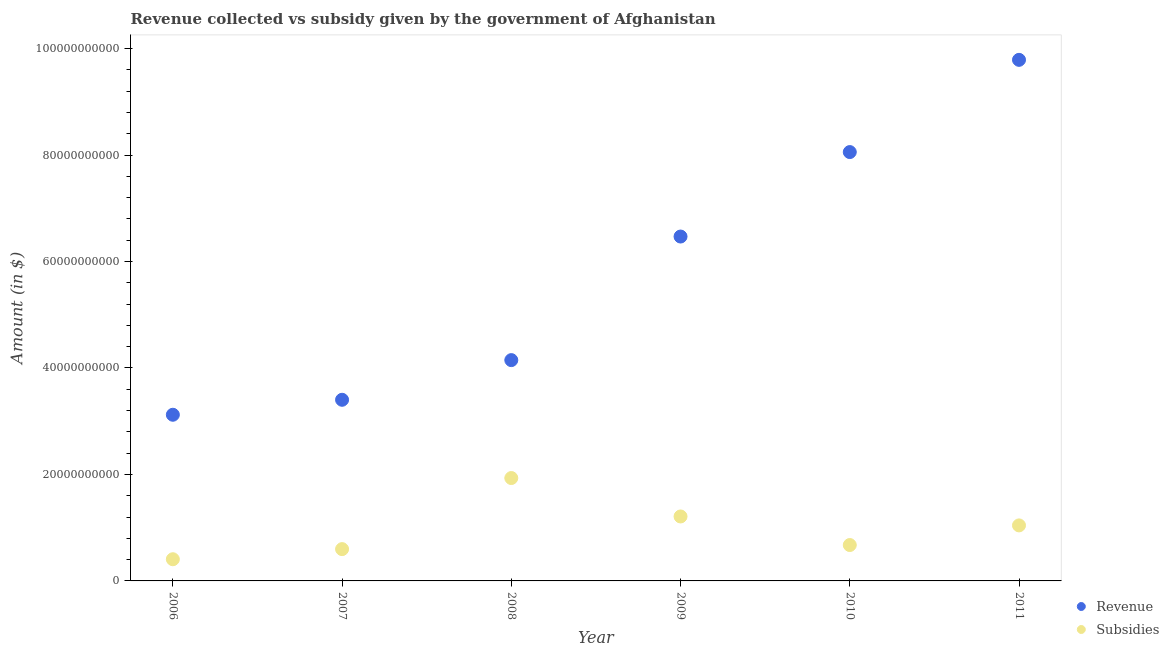What is the amount of revenue collected in 2007?
Provide a short and direct response. 3.40e+1. Across all years, what is the maximum amount of revenue collected?
Offer a terse response. 9.79e+1. Across all years, what is the minimum amount of subsidies given?
Keep it short and to the point. 4.07e+09. In which year was the amount of revenue collected maximum?
Provide a succinct answer. 2011. What is the total amount of revenue collected in the graph?
Provide a succinct answer. 3.50e+11. What is the difference between the amount of subsidies given in 2009 and that in 2010?
Offer a terse response. 5.37e+09. What is the difference between the amount of revenue collected in 2010 and the amount of subsidies given in 2006?
Keep it short and to the point. 7.65e+1. What is the average amount of revenue collected per year?
Offer a terse response. 5.83e+1. In the year 2008, what is the difference between the amount of subsidies given and amount of revenue collected?
Provide a succinct answer. -2.22e+1. What is the ratio of the amount of subsidies given in 2006 to that in 2011?
Your answer should be very brief. 0.39. What is the difference between the highest and the second highest amount of revenue collected?
Provide a short and direct response. 1.73e+1. What is the difference between the highest and the lowest amount of revenue collected?
Your answer should be compact. 6.67e+1. Is the sum of the amount of revenue collected in 2007 and 2010 greater than the maximum amount of subsidies given across all years?
Keep it short and to the point. Yes. Is the amount of revenue collected strictly less than the amount of subsidies given over the years?
Make the answer very short. No. What is the difference between two consecutive major ticks on the Y-axis?
Give a very brief answer. 2.00e+1. Are the values on the major ticks of Y-axis written in scientific E-notation?
Your answer should be compact. No. Does the graph contain any zero values?
Keep it short and to the point. No. How are the legend labels stacked?
Keep it short and to the point. Vertical. What is the title of the graph?
Ensure brevity in your answer.  Revenue collected vs subsidy given by the government of Afghanistan. Does "constant 2005 US$" appear as one of the legend labels in the graph?
Offer a very short reply. No. What is the label or title of the Y-axis?
Make the answer very short. Amount (in $). What is the Amount (in $) of Revenue in 2006?
Your response must be concise. 3.12e+1. What is the Amount (in $) of Subsidies in 2006?
Provide a short and direct response. 4.07e+09. What is the Amount (in $) in Revenue in 2007?
Give a very brief answer. 3.40e+1. What is the Amount (in $) of Subsidies in 2007?
Provide a short and direct response. 5.97e+09. What is the Amount (in $) of Revenue in 2008?
Provide a succinct answer. 4.15e+1. What is the Amount (in $) in Subsidies in 2008?
Give a very brief answer. 1.93e+1. What is the Amount (in $) in Revenue in 2009?
Provide a succinct answer. 6.47e+1. What is the Amount (in $) in Subsidies in 2009?
Offer a very short reply. 1.21e+1. What is the Amount (in $) in Revenue in 2010?
Your answer should be very brief. 8.06e+1. What is the Amount (in $) of Subsidies in 2010?
Make the answer very short. 6.74e+09. What is the Amount (in $) in Revenue in 2011?
Offer a terse response. 9.79e+1. What is the Amount (in $) in Subsidies in 2011?
Your answer should be compact. 1.04e+1. Across all years, what is the maximum Amount (in $) of Revenue?
Keep it short and to the point. 9.79e+1. Across all years, what is the maximum Amount (in $) of Subsidies?
Keep it short and to the point. 1.93e+1. Across all years, what is the minimum Amount (in $) in Revenue?
Your response must be concise. 3.12e+1. Across all years, what is the minimum Amount (in $) of Subsidies?
Ensure brevity in your answer.  4.07e+09. What is the total Amount (in $) in Revenue in the graph?
Ensure brevity in your answer.  3.50e+11. What is the total Amount (in $) in Subsidies in the graph?
Your answer should be very brief. 5.86e+1. What is the difference between the Amount (in $) of Revenue in 2006 and that in 2007?
Provide a short and direct response. -2.81e+09. What is the difference between the Amount (in $) in Subsidies in 2006 and that in 2007?
Keep it short and to the point. -1.90e+09. What is the difference between the Amount (in $) in Revenue in 2006 and that in 2008?
Your response must be concise. -1.03e+1. What is the difference between the Amount (in $) in Subsidies in 2006 and that in 2008?
Offer a terse response. -1.53e+1. What is the difference between the Amount (in $) in Revenue in 2006 and that in 2009?
Ensure brevity in your answer.  -3.35e+1. What is the difference between the Amount (in $) in Subsidies in 2006 and that in 2009?
Provide a short and direct response. -8.03e+09. What is the difference between the Amount (in $) in Revenue in 2006 and that in 2010?
Make the answer very short. -4.93e+1. What is the difference between the Amount (in $) of Subsidies in 2006 and that in 2010?
Provide a succinct answer. -2.67e+09. What is the difference between the Amount (in $) in Revenue in 2006 and that in 2011?
Your answer should be very brief. -6.67e+1. What is the difference between the Amount (in $) in Subsidies in 2006 and that in 2011?
Offer a terse response. -6.36e+09. What is the difference between the Amount (in $) of Revenue in 2007 and that in 2008?
Provide a short and direct response. -7.45e+09. What is the difference between the Amount (in $) in Subsidies in 2007 and that in 2008?
Provide a short and direct response. -1.34e+1. What is the difference between the Amount (in $) in Revenue in 2007 and that in 2009?
Offer a terse response. -3.07e+1. What is the difference between the Amount (in $) of Subsidies in 2007 and that in 2009?
Your response must be concise. -6.13e+09. What is the difference between the Amount (in $) in Revenue in 2007 and that in 2010?
Your answer should be very brief. -4.65e+1. What is the difference between the Amount (in $) in Subsidies in 2007 and that in 2010?
Make the answer very short. -7.68e+08. What is the difference between the Amount (in $) in Revenue in 2007 and that in 2011?
Provide a short and direct response. -6.39e+1. What is the difference between the Amount (in $) in Subsidies in 2007 and that in 2011?
Provide a short and direct response. -4.46e+09. What is the difference between the Amount (in $) of Revenue in 2008 and that in 2009?
Your response must be concise. -2.32e+1. What is the difference between the Amount (in $) in Subsidies in 2008 and that in 2009?
Offer a very short reply. 7.22e+09. What is the difference between the Amount (in $) of Revenue in 2008 and that in 2010?
Keep it short and to the point. -3.91e+1. What is the difference between the Amount (in $) of Subsidies in 2008 and that in 2010?
Provide a short and direct response. 1.26e+1. What is the difference between the Amount (in $) of Revenue in 2008 and that in 2011?
Give a very brief answer. -5.64e+1. What is the difference between the Amount (in $) of Subsidies in 2008 and that in 2011?
Keep it short and to the point. 8.90e+09. What is the difference between the Amount (in $) in Revenue in 2009 and that in 2010?
Make the answer very short. -1.59e+1. What is the difference between the Amount (in $) of Subsidies in 2009 and that in 2010?
Make the answer very short. 5.37e+09. What is the difference between the Amount (in $) in Revenue in 2009 and that in 2011?
Keep it short and to the point. -3.32e+1. What is the difference between the Amount (in $) in Subsidies in 2009 and that in 2011?
Provide a succinct answer. 1.68e+09. What is the difference between the Amount (in $) of Revenue in 2010 and that in 2011?
Your response must be concise. -1.73e+1. What is the difference between the Amount (in $) of Subsidies in 2010 and that in 2011?
Your response must be concise. -3.69e+09. What is the difference between the Amount (in $) in Revenue in 2006 and the Amount (in $) in Subsidies in 2007?
Give a very brief answer. 2.52e+1. What is the difference between the Amount (in $) in Revenue in 2006 and the Amount (in $) in Subsidies in 2008?
Keep it short and to the point. 1.19e+1. What is the difference between the Amount (in $) in Revenue in 2006 and the Amount (in $) in Subsidies in 2009?
Keep it short and to the point. 1.91e+1. What is the difference between the Amount (in $) in Revenue in 2006 and the Amount (in $) in Subsidies in 2010?
Ensure brevity in your answer.  2.45e+1. What is the difference between the Amount (in $) in Revenue in 2006 and the Amount (in $) in Subsidies in 2011?
Give a very brief answer. 2.08e+1. What is the difference between the Amount (in $) of Revenue in 2007 and the Amount (in $) of Subsidies in 2008?
Your answer should be very brief. 1.47e+1. What is the difference between the Amount (in $) in Revenue in 2007 and the Amount (in $) in Subsidies in 2009?
Keep it short and to the point. 2.19e+1. What is the difference between the Amount (in $) of Revenue in 2007 and the Amount (in $) of Subsidies in 2010?
Offer a very short reply. 2.73e+1. What is the difference between the Amount (in $) in Revenue in 2007 and the Amount (in $) in Subsidies in 2011?
Your response must be concise. 2.36e+1. What is the difference between the Amount (in $) of Revenue in 2008 and the Amount (in $) of Subsidies in 2009?
Your response must be concise. 2.94e+1. What is the difference between the Amount (in $) in Revenue in 2008 and the Amount (in $) in Subsidies in 2010?
Give a very brief answer. 3.47e+1. What is the difference between the Amount (in $) of Revenue in 2008 and the Amount (in $) of Subsidies in 2011?
Provide a succinct answer. 3.10e+1. What is the difference between the Amount (in $) of Revenue in 2009 and the Amount (in $) of Subsidies in 2010?
Offer a very short reply. 5.79e+1. What is the difference between the Amount (in $) of Revenue in 2009 and the Amount (in $) of Subsidies in 2011?
Ensure brevity in your answer.  5.43e+1. What is the difference between the Amount (in $) in Revenue in 2010 and the Amount (in $) in Subsidies in 2011?
Your answer should be very brief. 7.01e+1. What is the average Amount (in $) of Revenue per year?
Give a very brief answer. 5.83e+1. What is the average Amount (in $) in Subsidies per year?
Your answer should be very brief. 9.77e+09. In the year 2006, what is the difference between the Amount (in $) of Revenue and Amount (in $) of Subsidies?
Provide a short and direct response. 2.71e+1. In the year 2007, what is the difference between the Amount (in $) in Revenue and Amount (in $) in Subsidies?
Keep it short and to the point. 2.81e+1. In the year 2008, what is the difference between the Amount (in $) of Revenue and Amount (in $) of Subsidies?
Ensure brevity in your answer.  2.22e+1. In the year 2009, what is the difference between the Amount (in $) of Revenue and Amount (in $) of Subsidies?
Your answer should be very brief. 5.26e+1. In the year 2010, what is the difference between the Amount (in $) in Revenue and Amount (in $) in Subsidies?
Offer a terse response. 7.38e+1. In the year 2011, what is the difference between the Amount (in $) of Revenue and Amount (in $) of Subsidies?
Provide a succinct answer. 8.74e+1. What is the ratio of the Amount (in $) in Revenue in 2006 to that in 2007?
Keep it short and to the point. 0.92. What is the ratio of the Amount (in $) of Subsidies in 2006 to that in 2007?
Give a very brief answer. 0.68. What is the ratio of the Amount (in $) of Revenue in 2006 to that in 2008?
Give a very brief answer. 0.75. What is the ratio of the Amount (in $) of Subsidies in 2006 to that in 2008?
Give a very brief answer. 0.21. What is the ratio of the Amount (in $) of Revenue in 2006 to that in 2009?
Offer a very short reply. 0.48. What is the ratio of the Amount (in $) of Subsidies in 2006 to that in 2009?
Offer a terse response. 0.34. What is the ratio of the Amount (in $) in Revenue in 2006 to that in 2010?
Your answer should be very brief. 0.39. What is the ratio of the Amount (in $) of Subsidies in 2006 to that in 2010?
Ensure brevity in your answer.  0.6. What is the ratio of the Amount (in $) in Revenue in 2006 to that in 2011?
Offer a terse response. 0.32. What is the ratio of the Amount (in $) in Subsidies in 2006 to that in 2011?
Make the answer very short. 0.39. What is the ratio of the Amount (in $) in Revenue in 2007 to that in 2008?
Provide a succinct answer. 0.82. What is the ratio of the Amount (in $) in Subsidies in 2007 to that in 2008?
Keep it short and to the point. 0.31. What is the ratio of the Amount (in $) in Revenue in 2007 to that in 2009?
Your answer should be very brief. 0.53. What is the ratio of the Amount (in $) of Subsidies in 2007 to that in 2009?
Ensure brevity in your answer.  0.49. What is the ratio of the Amount (in $) of Revenue in 2007 to that in 2010?
Make the answer very short. 0.42. What is the ratio of the Amount (in $) of Subsidies in 2007 to that in 2010?
Give a very brief answer. 0.89. What is the ratio of the Amount (in $) in Revenue in 2007 to that in 2011?
Make the answer very short. 0.35. What is the ratio of the Amount (in $) in Subsidies in 2007 to that in 2011?
Offer a very short reply. 0.57. What is the ratio of the Amount (in $) of Revenue in 2008 to that in 2009?
Your answer should be compact. 0.64. What is the ratio of the Amount (in $) in Subsidies in 2008 to that in 2009?
Offer a very short reply. 1.6. What is the ratio of the Amount (in $) of Revenue in 2008 to that in 2010?
Offer a very short reply. 0.51. What is the ratio of the Amount (in $) in Subsidies in 2008 to that in 2010?
Offer a terse response. 2.87. What is the ratio of the Amount (in $) in Revenue in 2008 to that in 2011?
Offer a very short reply. 0.42. What is the ratio of the Amount (in $) of Subsidies in 2008 to that in 2011?
Offer a very short reply. 1.85. What is the ratio of the Amount (in $) of Revenue in 2009 to that in 2010?
Make the answer very short. 0.8. What is the ratio of the Amount (in $) of Subsidies in 2009 to that in 2010?
Provide a short and direct response. 1.8. What is the ratio of the Amount (in $) of Revenue in 2009 to that in 2011?
Your response must be concise. 0.66. What is the ratio of the Amount (in $) in Subsidies in 2009 to that in 2011?
Provide a succinct answer. 1.16. What is the ratio of the Amount (in $) of Revenue in 2010 to that in 2011?
Provide a succinct answer. 0.82. What is the ratio of the Amount (in $) in Subsidies in 2010 to that in 2011?
Offer a terse response. 0.65. What is the difference between the highest and the second highest Amount (in $) in Revenue?
Your answer should be very brief. 1.73e+1. What is the difference between the highest and the second highest Amount (in $) in Subsidies?
Keep it short and to the point. 7.22e+09. What is the difference between the highest and the lowest Amount (in $) of Revenue?
Offer a terse response. 6.67e+1. What is the difference between the highest and the lowest Amount (in $) in Subsidies?
Make the answer very short. 1.53e+1. 